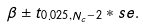Convert formula to latex. <formula><loc_0><loc_0><loc_500><loc_500>\beta \pm t _ { 0 . 0 2 5 , N _ { c } - 2 } * s e .</formula> 